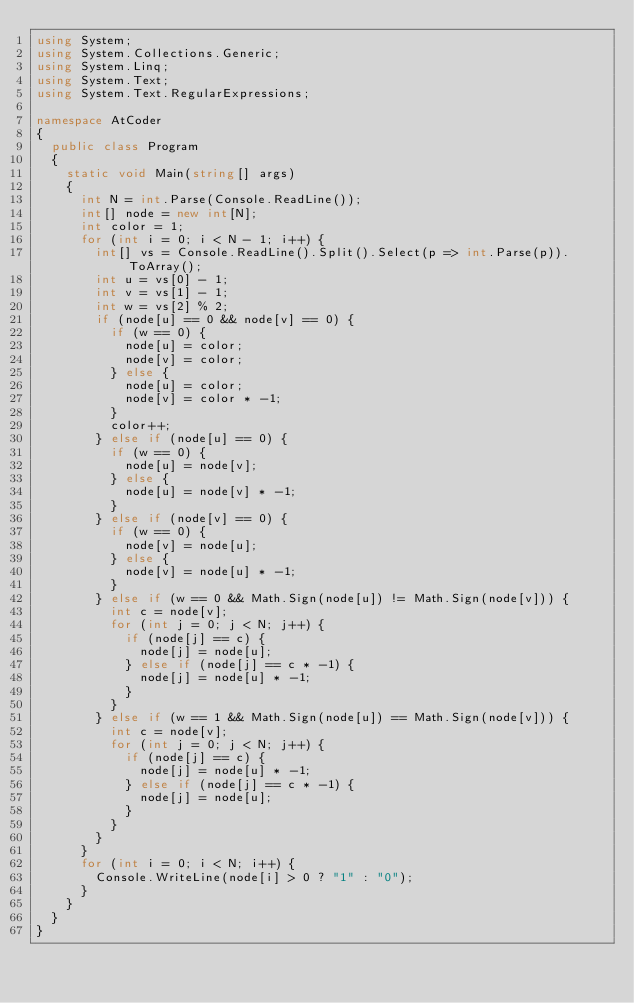<code> <loc_0><loc_0><loc_500><loc_500><_C#_>using System;
using System.Collections.Generic;
using System.Linq;
using System.Text;
using System.Text.RegularExpressions;

namespace AtCoder
{
	public class Program
	{
		static void Main(string[] args)
		{
			int N = int.Parse(Console.ReadLine());
			int[] node = new int[N];
			int color = 1;
			for (int i = 0; i < N - 1; i++) {
				int[] vs = Console.ReadLine().Split().Select(p => int.Parse(p)).ToArray();
				int u = vs[0] - 1;
				int v = vs[1] - 1;
				int w = vs[2] % 2;
				if (node[u] == 0 && node[v] == 0) {
					if (w == 0) {
						node[u] = color;
						node[v] = color;
					} else {
						node[u] = color;
						node[v] = color * -1;
					}
					color++;
				} else if (node[u] == 0) {
					if (w == 0) {
						node[u] = node[v];
					} else {
						node[u] = node[v] * -1;
					}
				} else if (node[v] == 0) {
					if (w == 0) {
						node[v] = node[u];
					} else {
						node[v] = node[u] * -1;
					}
				} else if (w == 0 && Math.Sign(node[u]) != Math.Sign(node[v])) {
					int c = node[v];
					for (int j = 0; j < N; j++) {
						if (node[j] == c) {
							node[j] = node[u];
						} else if (node[j] == c * -1) {
							node[j] = node[u] * -1;
						}
					}
				} else if (w == 1 && Math.Sign(node[u]) == Math.Sign(node[v])) {
					int c = node[v];
					for (int j = 0; j < N; j++) {
						if (node[j] == c) {
							node[j] = node[u] * -1;
						} else if (node[j] == c * -1) {
							node[j] = node[u];
						}
					}
				}
			}
			for (int i = 0; i < N; i++) {
				Console.WriteLine(node[i] > 0 ? "1" : "0");
			}
		}
	}
}</code> 